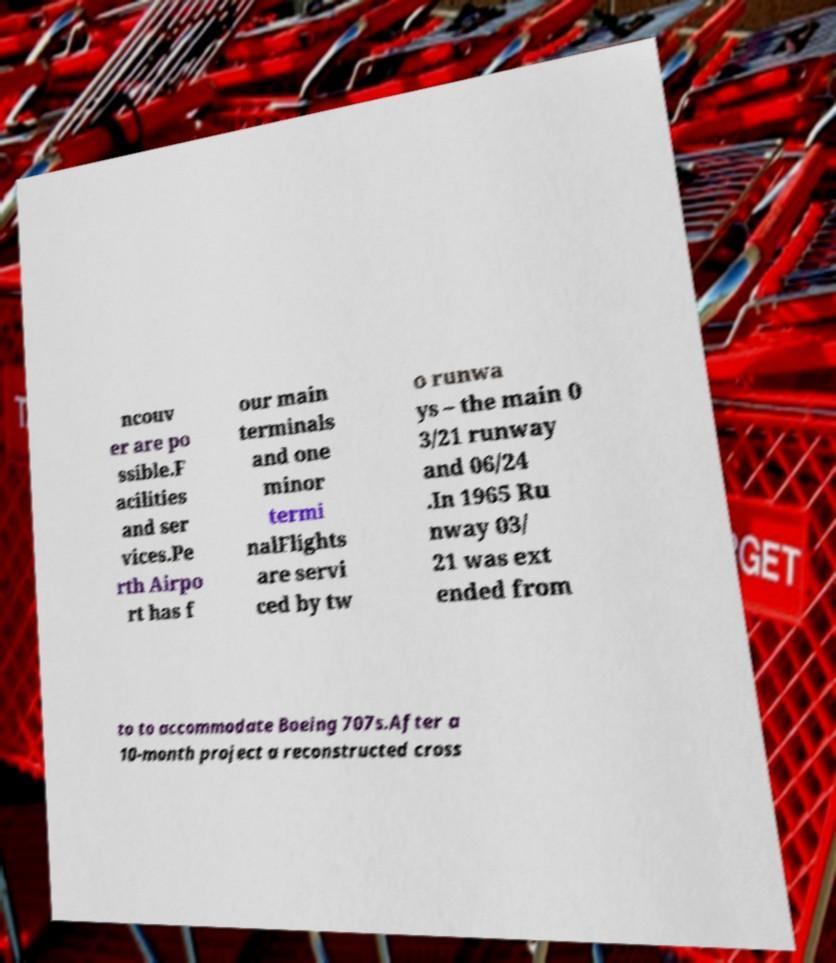There's text embedded in this image that I need extracted. Can you transcribe it verbatim? ncouv er are po ssible.F acilities and ser vices.Pe rth Airpo rt has f our main terminals and one minor termi nalFlights are servi ced by tw o runwa ys – the main 0 3/21 runway and 06/24 .In 1965 Ru nway 03/ 21 was ext ended from to to accommodate Boeing 707s.After a 10-month project a reconstructed cross 